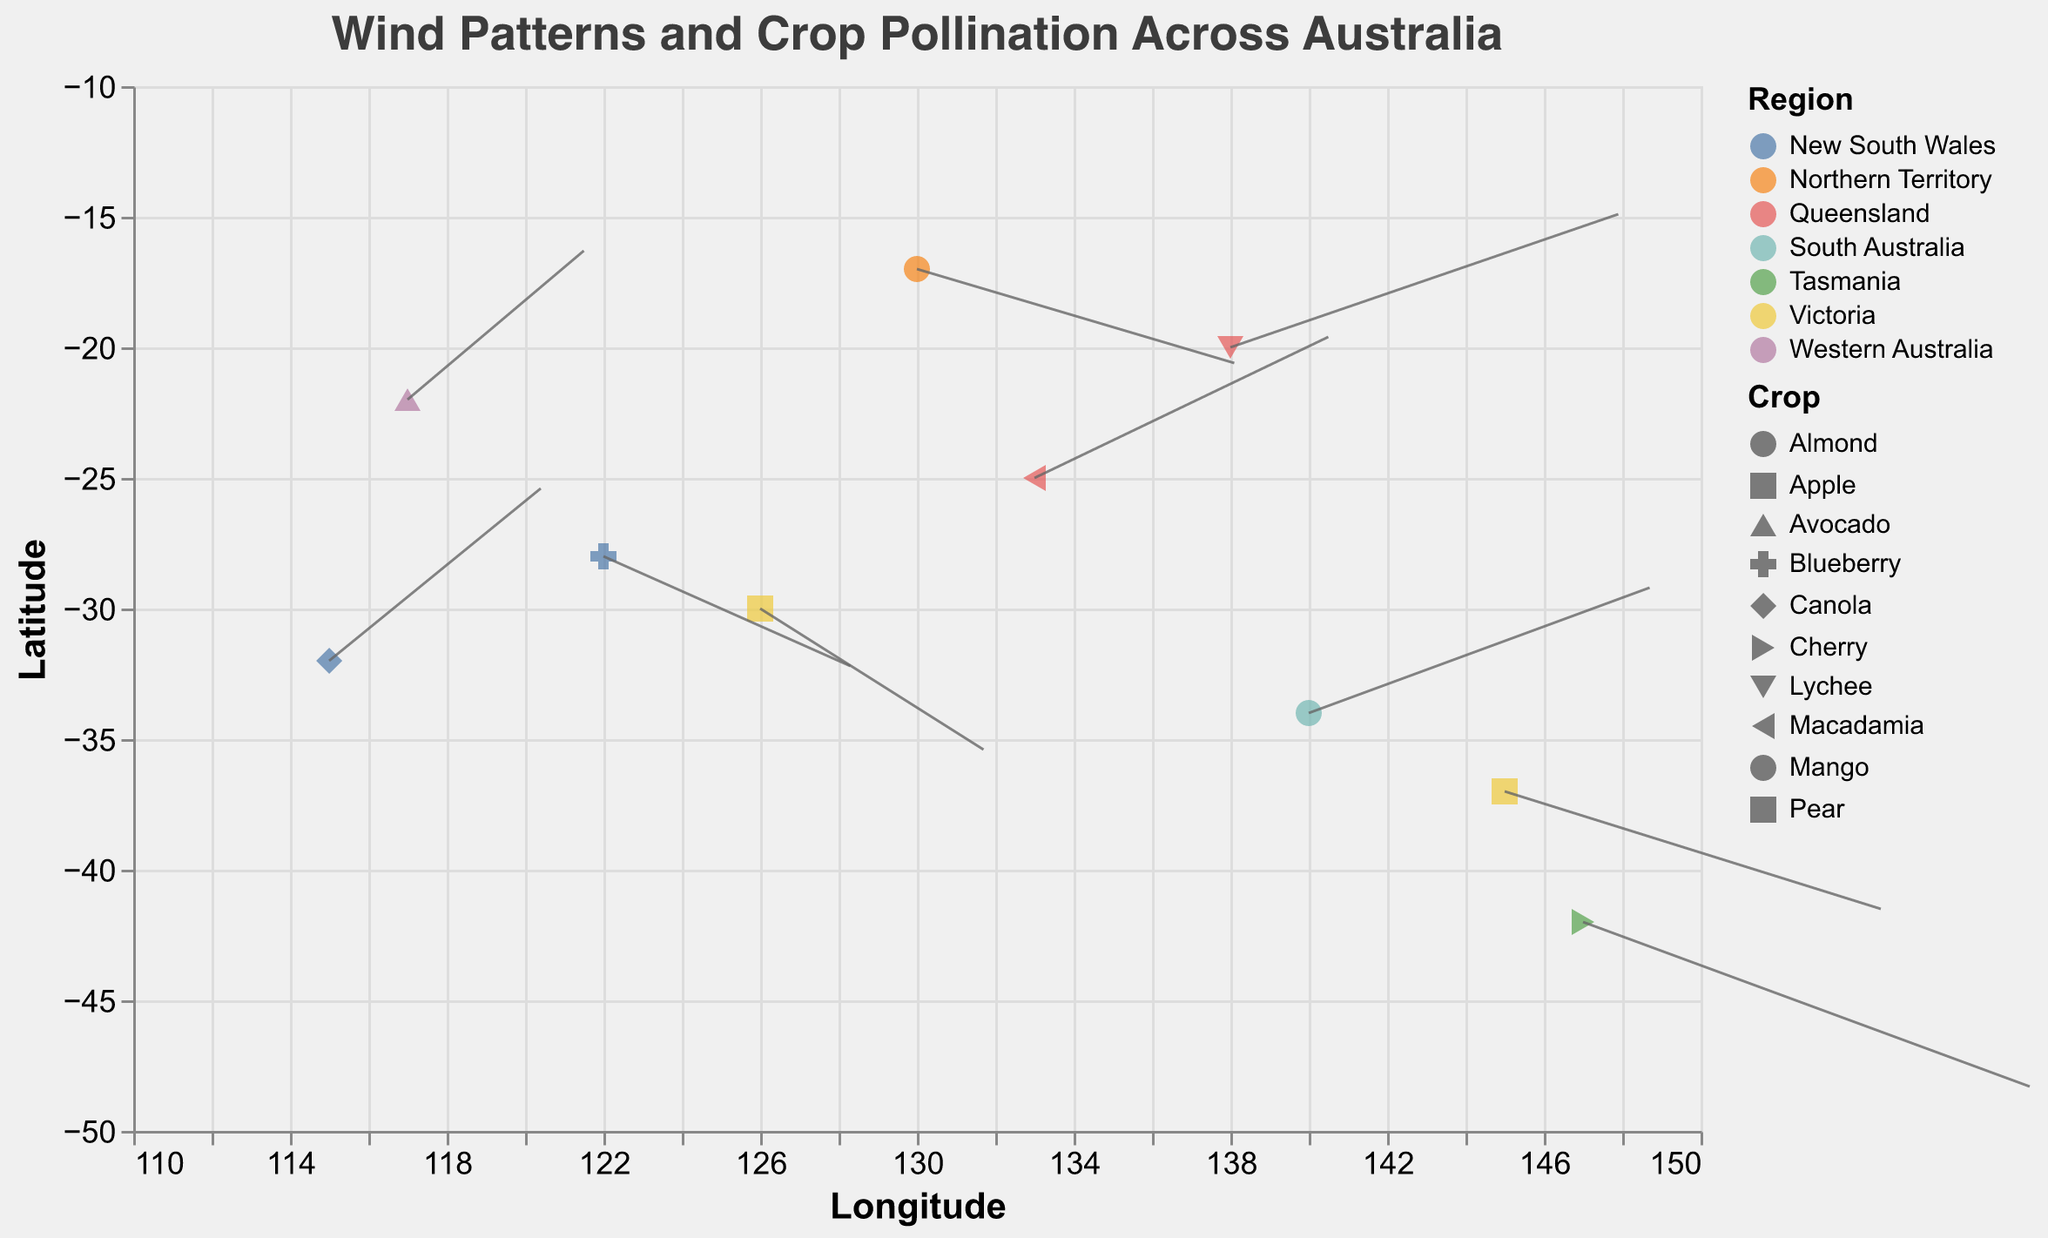What is the title of the figure? The title of the figure is displayed at the top and reads "Wind Patterns and Crop Pollination Across Australia".
Answer: Wind Patterns and Crop Pollination Across Australia What are the range values for the longitude axis? The longitude axis is represented on the x-axis, which has a range from 110 to 150.
Answer: 110 to 150 Which regions have crops with winds blowing primarily southward? By observing the v component of the wind vectors, we see negative values for "v", indicating southward wind for Victoria, Northern Territory, New South Wales, and Tasmania.
Answer: Victoria, Northern Territory, New South Wales, Tasmania Which crop is represented in the Northern Territory and what is the wind pattern? By looking at the tooltip or legend, we see that Mango is the crop in the Northern Territory and the wind pattern shows u=2.7 and v=-1.2, blowing to the southeast.
Answer: Mango; southeast How many data points are represented for crops in Queensland? By looking at the plot legend and identifying the color and shape for Queensland, we can count the points, which are Macadamia and Lychee, thus 2 points.
Answer: 2 Which region has the wind vector with the largest u component, and what is the value? By comparing all u values, Tasmania has the largest u component with a value of 3.8.
Answer: Tasmania, 3.8 What is the average latitude for the crops in Victoria? The crops in Victoria are at latitudes -37 and -30. The average latitude can be calculated as (-37 + (-30))/2 = -33.5.
Answer: -33.5 Which crop in New South Wales has wind blowing to the north-west, and what are the u and v values? For northwest direction, both u and v should be positive. In New South Wales, Canola has wind blowing north-west with u=1.8 and v=2.2.
Answer: Canola; u=1.8, v=2.2 Which region experiences the most significant southward wind (largest negative v value) and which crop is affected? Tasmania experiences the most significant southward wind with v=-2.1 affecting the Cherry crop.
Answer: Tasmania, Cherry What similarity do the wind patterns in Queensland (133,-25) and Queensland (138,-20) share? Both data points in Queensland have positive u and v values, indicating wind blowing to the northeast direction.
Answer: Northeast 